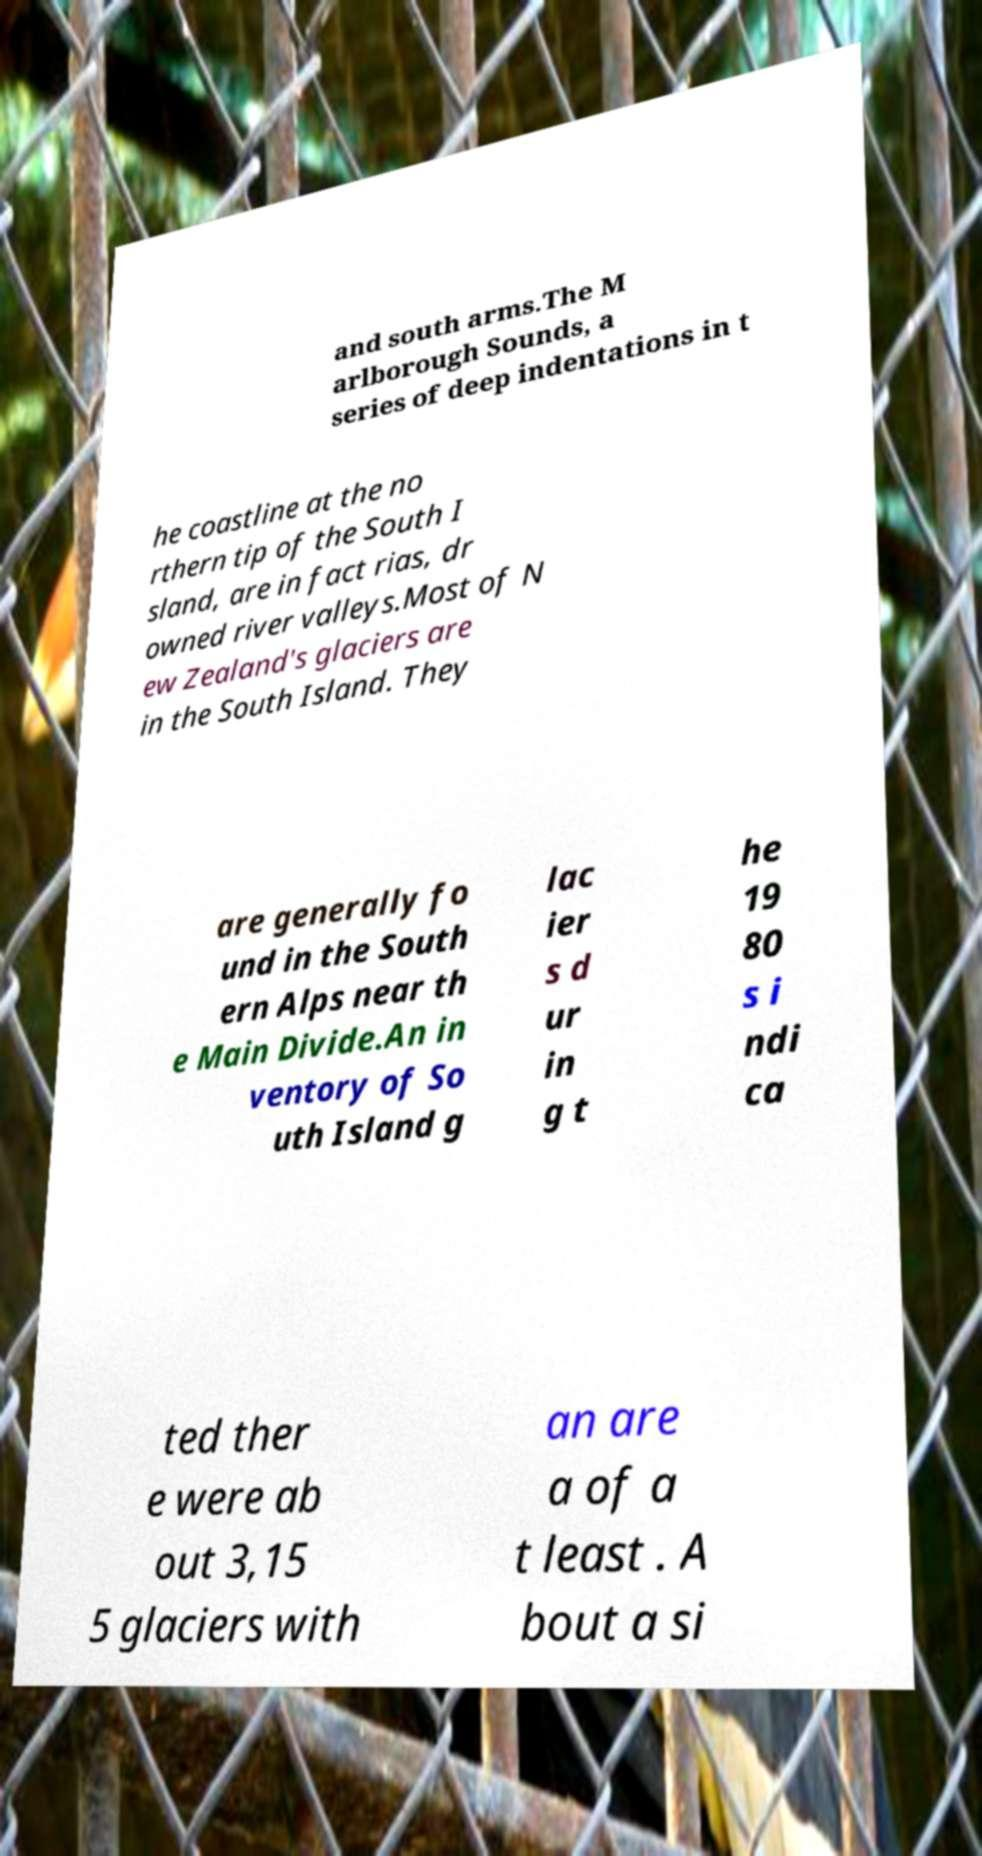Please read and relay the text visible in this image. What does it say? and south arms.The M arlborough Sounds, a series of deep indentations in t he coastline at the no rthern tip of the South I sland, are in fact rias, dr owned river valleys.Most of N ew Zealand's glaciers are in the South Island. They are generally fo und in the South ern Alps near th e Main Divide.An in ventory of So uth Island g lac ier s d ur in g t he 19 80 s i ndi ca ted ther e were ab out 3,15 5 glaciers with an are a of a t least . A bout a si 